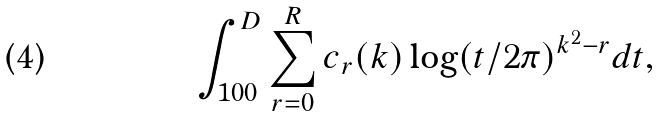<formula> <loc_0><loc_0><loc_500><loc_500>\int _ { 1 0 0 } ^ { D } \sum _ { r = 0 } ^ { R } c _ { r } ( k ) \log ( t / 2 \pi ) ^ { k ^ { 2 } - r } d t ,</formula> 